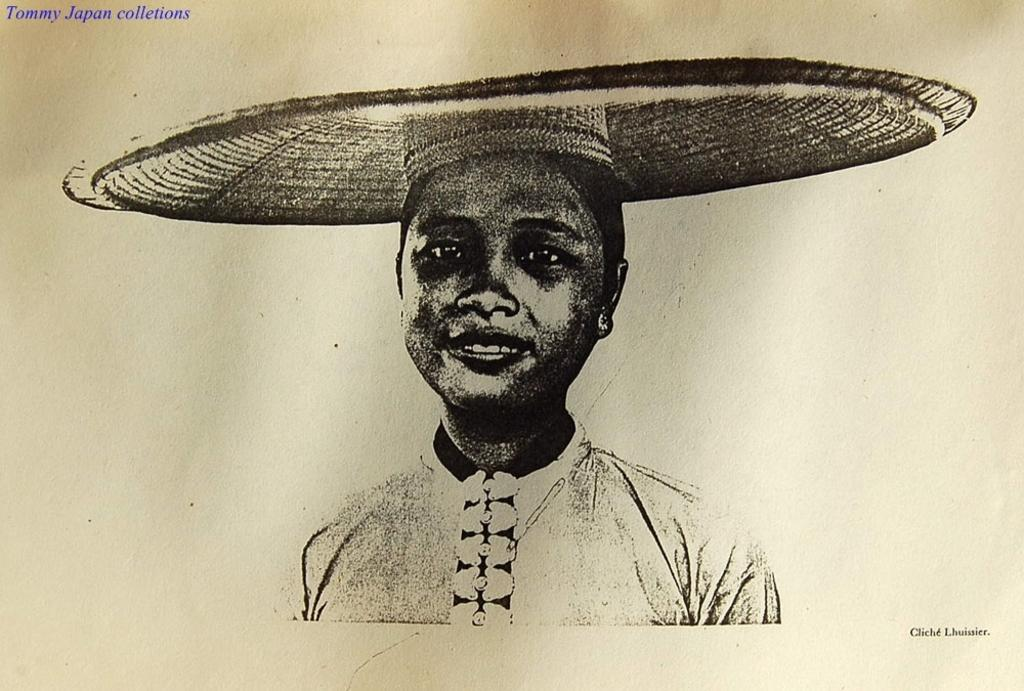What is the main subject of the painting in the image? There is a painting of a woman in the image. Can you describe any text present in the image? Yes, there is text in the top left corner and the bottom right corner of the image. What type of structure can be seen in the background of the painting? There is no structure visible in the painting; it only features a woman. How many people are present in the crowd depicted in the painting? There is no crowd depicted in the painting; it only features a woman. 